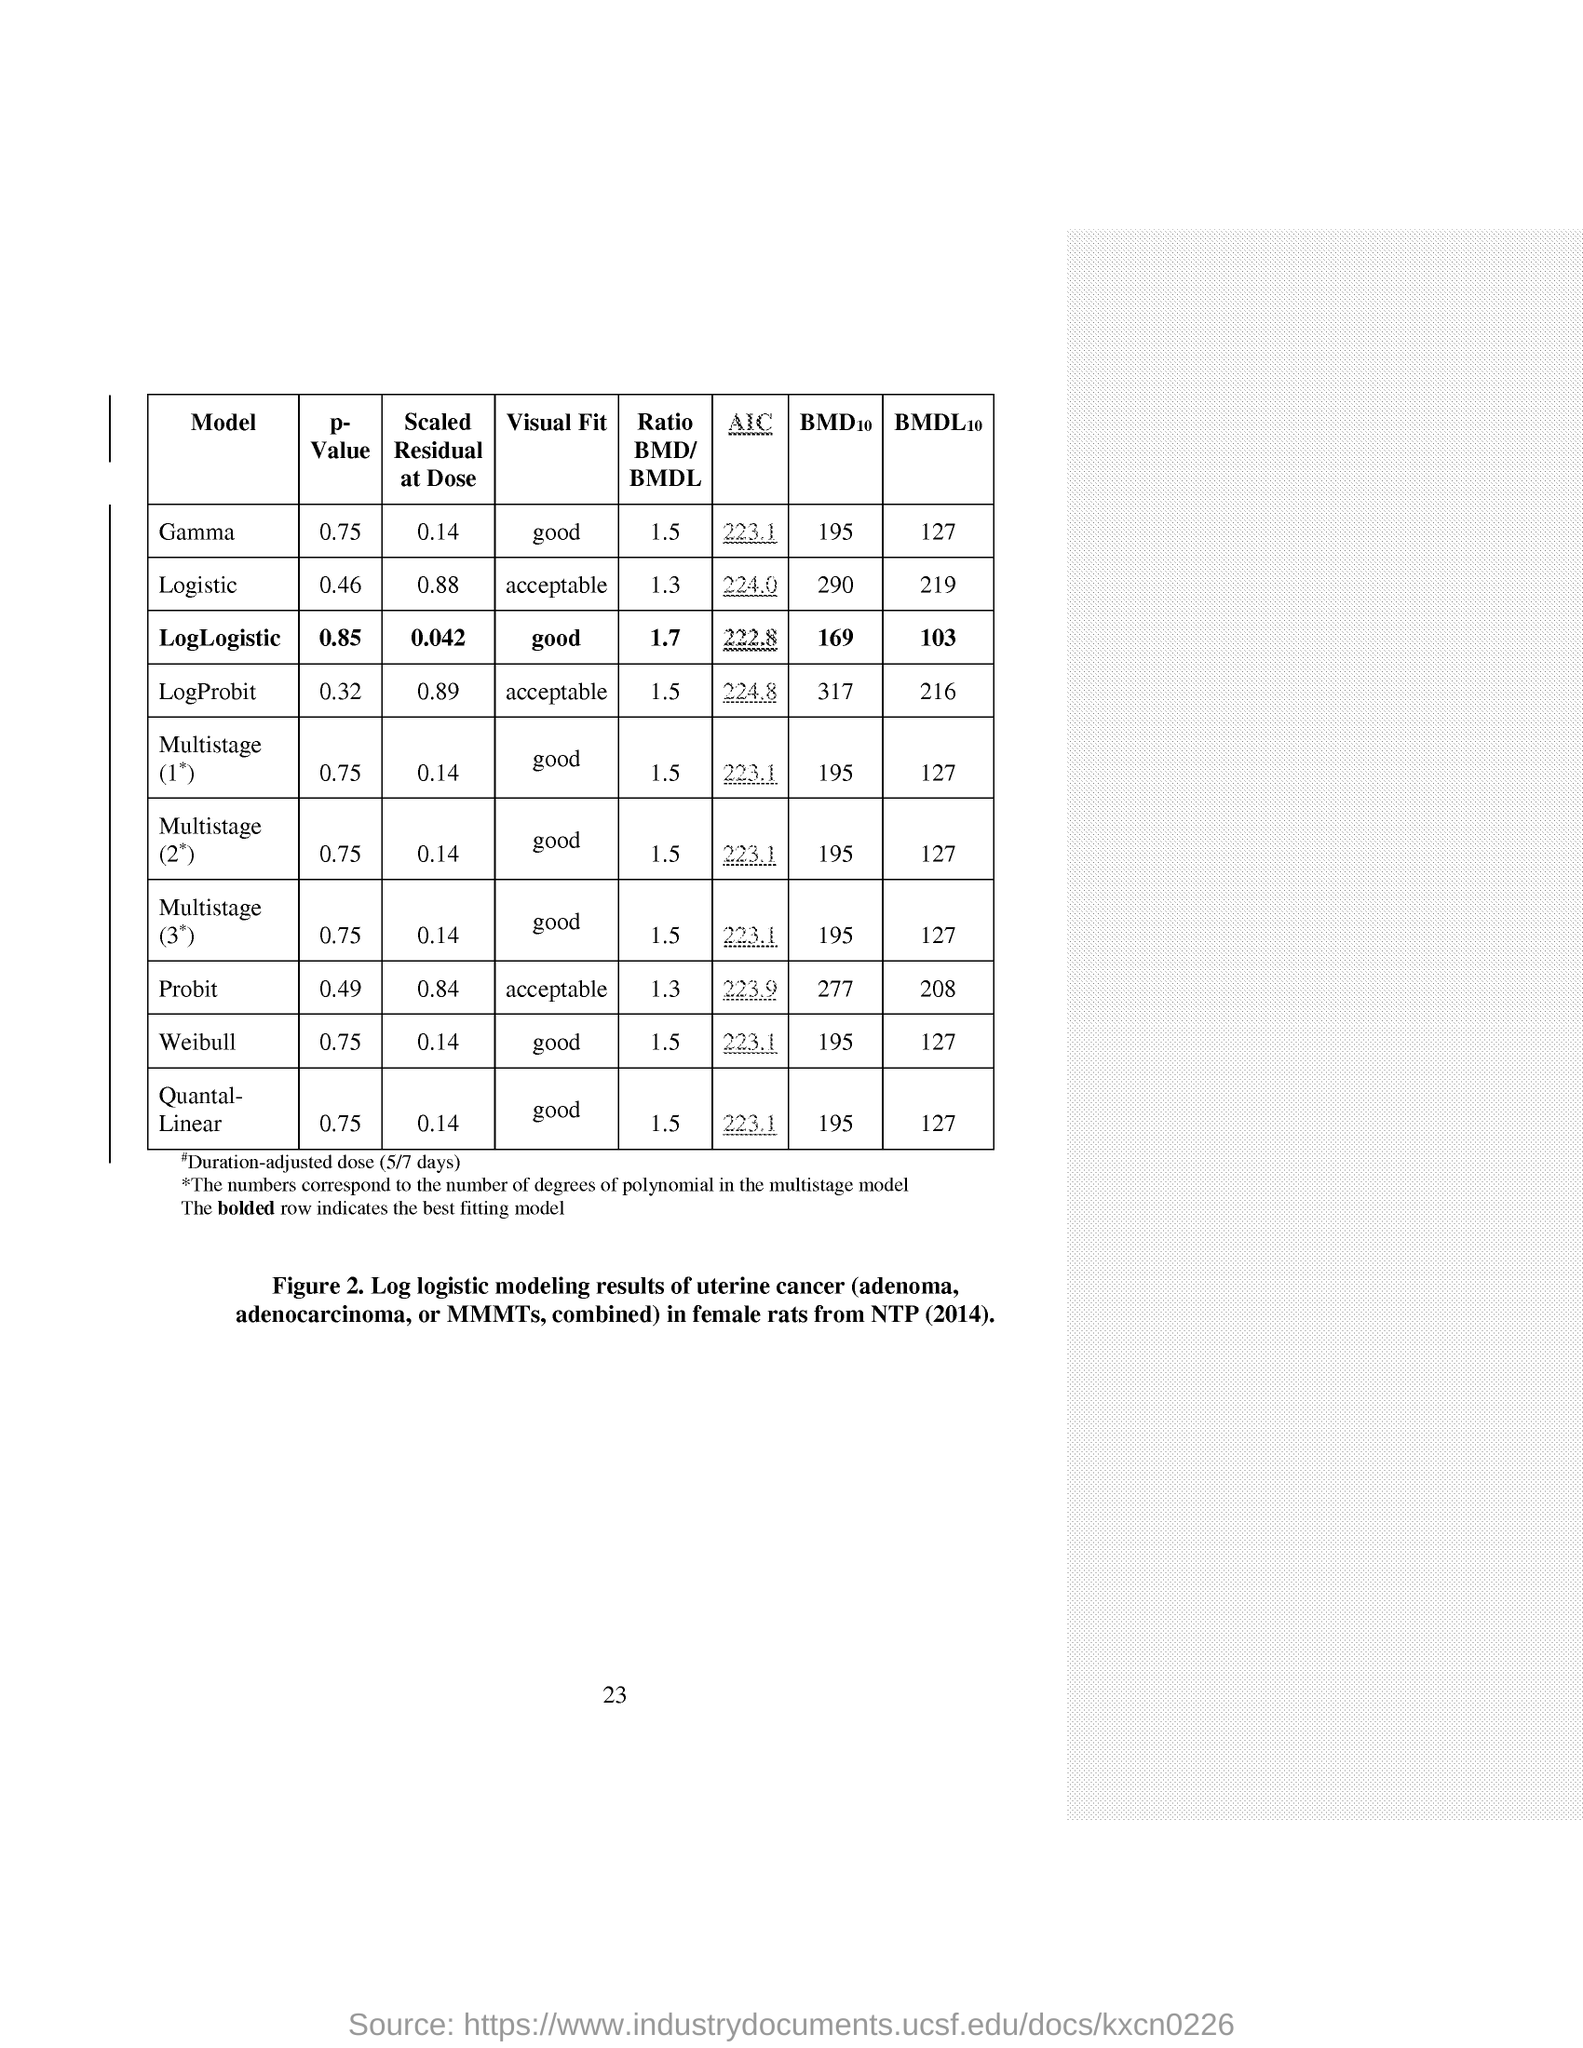What is the p-Value of Gamma?
Offer a terse response. 0.75. What is the Scaled Residual at Dose of LogLogistic?
Provide a succinct answer. 0.042. What is the Visual Fit of Logistic?
Give a very brief answer. Acceptable. What is the Ratio BMD/BMDL of Multistage(1*)?
Give a very brief answer. 1.5. What is AIC of Weibull?
Keep it short and to the point. 223.1. 